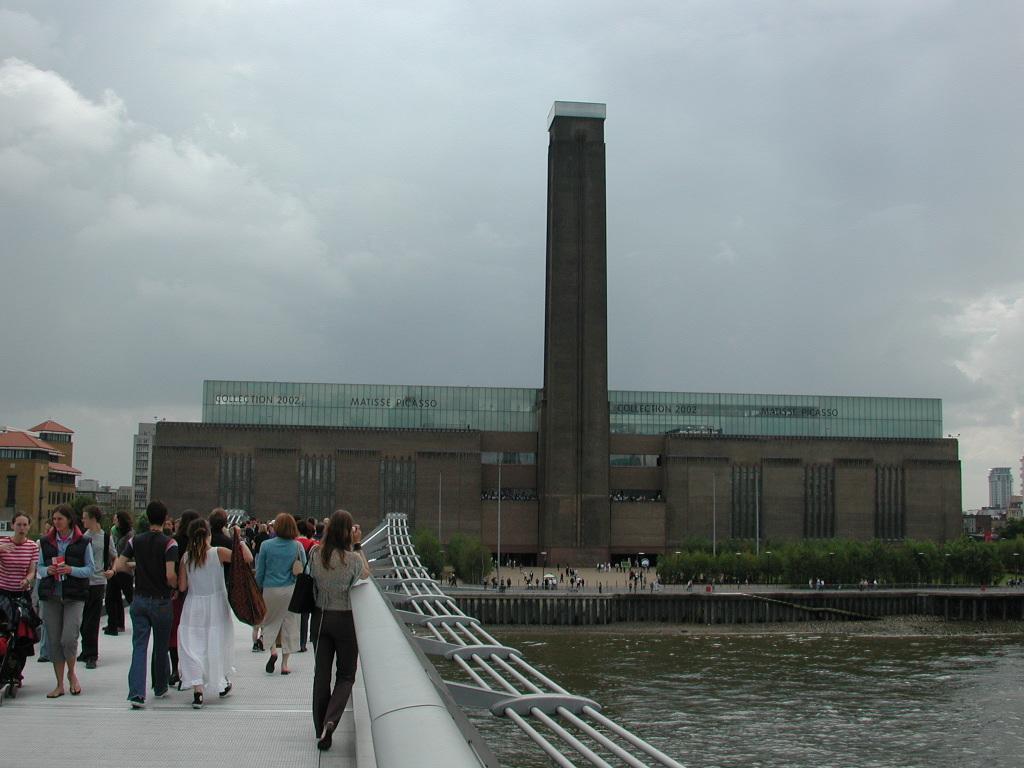How would you summarize this image in a sentence or two? Bottom left side of the image few people are walking and there is a fencing. Bottom right side of the image there is water. Behind the water there is a fencing and there are some poles and trees and there are few people standing. In the middle of the image there are some buildings. Top of the image there are some clouds and sky. 